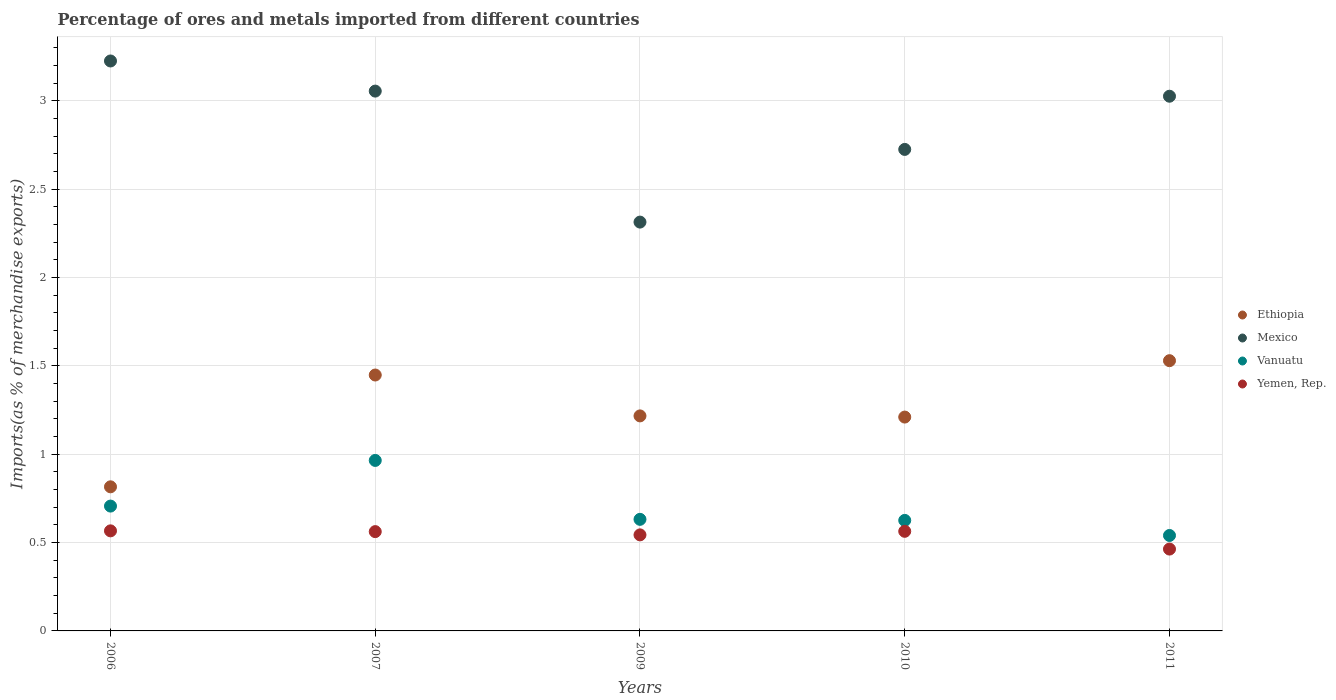Is the number of dotlines equal to the number of legend labels?
Your response must be concise. Yes. What is the percentage of imports to different countries in Yemen, Rep. in 2011?
Keep it short and to the point. 0.46. Across all years, what is the maximum percentage of imports to different countries in Mexico?
Keep it short and to the point. 3.23. Across all years, what is the minimum percentage of imports to different countries in Vanuatu?
Ensure brevity in your answer.  0.54. In which year was the percentage of imports to different countries in Ethiopia maximum?
Keep it short and to the point. 2011. In which year was the percentage of imports to different countries in Yemen, Rep. minimum?
Provide a short and direct response. 2011. What is the total percentage of imports to different countries in Ethiopia in the graph?
Your answer should be compact. 6.22. What is the difference between the percentage of imports to different countries in Mexico in 2006 and that in 2011?
Offer a terse response. 0.2. What is the difference between the percentage of imports to different countries in Mexico in 2010 and the percentage of imports to different countries in Vanuatu in 2007?
Offer a very short reply. 1.76. What is the average percentage of imports to different countries in Yemen, Rep. per year?
Your answer should be very brief. 0.54. In the year 2011, what is the difference between the percentage of imports to different countries in Ethiopia and percentage of imports to different countries in Vanuatu?
Ensure brevity in your answer.  0.99. In how many years, is the percentage of imports to different countries in Yemen, Rep. greater than 1.6 %?
Your response must be concise. 0. What is the ratio of the percentage of imports to different countries in Ethiopia in 2009 to that in 2010?
Offer a terse response. 1.01. What is the difference between the highest and the second highest percentage of imports to different countries in Mexico?
Ensure brevity in your answer.  0.17. What is the difference between the highest and the lowest percentage of imports to different countries in Vanuatu?
Your answer should be compact. 0.42. Does the percentage of imports to different countries in Mexico monotonically increase over the years?
Make the answer very short. No. Is the percentage of imports to different countries in Vanuatu strictly greater than the percentage of imports to different countries in Yemen, Rep. over the years?
Keep it short and to the point. Yes. Is the percentage of imports to different countries in Mexico strictly less than the percentage of imports to different countries in Ethiopia over the years?
Ensure brevity in your answer.  No. How many dotlines are there?
Keep it short and to the point. 4. Are the values on the major ticks of Y-axis written in scientific E-notation?
Your response must be concise. No. Does the graph contain any zero values?
Provide a succinct answer. No. Does the graph contain grids?
Provide a short and direct response. Yes. How many legend labels are there?
Keep it short and to the point. 4. How are the legend labels stacked?
Your response must be concise. Vertical. What is the title of the graph?
Your answer should be compact. Percentage of ores and metals imported from different countries. Does "Peru" appear as one of the legend labels in the graph?
Your answer should be very brief. No. What is the label or title of the Y-axis?
Make the answer very short. Imports(as % of merchandise exports). What is the Imports(as % of merchandise exports) in Ethiopia in 2006?
Ensure brevity in your answer.  0.82. What is the Imports(as % of merchandise exports) in Mexico in 2006?
Provide a succinct answer. 3.23. What is the Imports(as % of merchandise exports) in Vanuatu in 2006?
Keep it short and to the point. 0.71. What is the Imports(as % of merchandise exports) in Yemen, Rep. in 2006?
Make the answer very short. 0.57. What is the Imports(as % of merchandise exports) of Ethiopia in 2007?
Offer a very short reply. 1.45. What is the Imports(as % of merchandise exports) of Mexico in 2007?
Your response must be concise. 3.05. What is the Imports(as % of merchandise exports) of Vanuatu in 2007?
Offer a very short reply. 0.96. What is the Imports(as % of merchandise exports) of Yemen, Rep. in 2007?
Offer a terse response. 0.56. What is the Imports(as % of merchandise exports) in Ethiopia in 2009?
Keep it short and to the point. 1.22. What is the Imports(as % of merchandise exports) in Mexico in 2009?
Your response must be concise. 2.31. What is the Imports(as % of merchandise exports) in Vanuatu in 2009?
Your answer should be compact. 0.63. What is the Imports(as % of merchandise exports) of Yemen, Rep. in 2009?
Your answer should be compact. 0.54. What is the Imports(as % of merchandise exports) in Ethiopia in 2010?
Offer a terse response. 1.21. What is the Imports(as % of merchandise exports) of Mexico in 2010?
Keep it short and to the point. 2.72. What is the Imports(as % of merchandise exports) of Vanuatu in 2010?
Your answer should be compact. 0.63. What is the Imports(as % of merchandise exports) in Yemen, Rep. in 2010?
Provide a succinct answer. 0.56. What is the Imports(as % of merchandise exports) in Ethiopia in 2011?
Offer a very short reply. 1.53. What is the Imports(as % of merchandise exports) in Mexico in 2011?
Make the answer very short. 3.03. What is the Imports(as % of merchandise exports) in Vanuatu in 2011?
Give a very brief answer. 0.54. What is the Imports(as % of merchandise exports) in Yemen, Rep. in 2011?
Give a very brief answer. 0.46. Across all years, what is the maximum Imports(as % of merchandise exports) of Ethiopia?
Make the answer very short. 1.53. Across all years, what is the maximum Imports(as % of merchandise exports) in Mexico?
Make the answer very short. 3.23. Across all years, what is the maximum Imports(as % of merchandise exports) in Vanuatu?
Provide a short and direct response. 0.96. Across all years, what is the maximum Imports(as % of merchandise exports) of Yemen, Rep.?
Your answer should be very brief. 0.57. Across all years, what is the minimum Imports(as % of merchandise exports) of Ethiopia?
Give a very brief answer. 0.82. Across all years, what is the minimum Imports(as % of merchandise exports) of Mexico?
Your answer should be very brief. 2.31. Across all years, what is the minimum Imports(as % of merchandise exports) in Vanuatu?
Make the answer very short. 0.54. Across all years, what is the minimum Imports(as % of merchandise exports) of Yemen, Rep.?
Offer a very short reply. 0.46. What is the total Imports(as % of merchandise exports) in Ethiopia in the graph?
Ensure brevity in your answer.  6.22. What is the total Imports(as % of merchandise exports) of Mexico in the graph?
Make the answer very short. 14.35. What is the total Imports(as % of merchandise exports) in Vanuatu in the graph?
Your response must be concise. 3.47. What is the total Imports(as % of merchandise exports) of Yemen, Rep. in the graph?
Provide a succinct answer. 2.7. What is the difference between the Imports(as % of merchandise exports) of Ethiopia in 2006 and that in 2007?
Your answer should be very brief. -0.63. What is the difference between the Imports(as % of merchandise exports) of Mexico in 2006 and that in 2007?
Keep it short and to the point. 0.17. What is the difference between the Imports(as % of merchandise exports) in Vanuatu in 2006 and that in 2007?
Give a very brief answer. -0.26. What is the difference between the Imports(as % of merchandise exports) of Yemen, Rep. in 2006 and that in 2007?
Give a very brief answer. 0. What is the difference between the Imports(as % of merchandise exports) of Ethiopia in 2006 and that in 2009?
Make the answer very short. -0.4. What is the difference between the Imports(as % of merchandise exports) in Mexico in 2006 and that in 2009?
Ensure brevity in your answer.  0.91. What is the difference between the Imports(as % of merchandise exports) of Vanuatu in 2006 and that in 2009?
Give a very brief answer. 0.07. What is the difference between the Imports(as % of merchandise exports) of Yemen, Rep. in 2006 and that in 2009?
Your answer should be compact. 0.02. What is the difference between the Imports(as % of merchandise exports) in Ethiopia in 2006 and that in 2010?
Keep it short and to the point. -0.39. What is the difference between the Imports(as % of merchandise exports) of Mexico in 2006 and that in 2010?
Offer a terse response. 0.5. What is the difference between the Imports(as % of merchandise exports) of Vanuatu in 2006 and that in 2010?
Offer a very short reply. 0.08. What is the difference between the Imports(as % of merchandise exports) of Yemen, Rep. in 2006 and that in 2010?
Ensure brevity in your answer.  0. What is the difference between the Imports(as % of merchandise exports) in Ethiopia in 2006 and that in 2011?
Your answer should be compact. -0.71. What is the difference between the Imports(as % of merchandise exports) in Mexico in 2006 and that in 2011?
Keep it short and to the point. 0.2. What is the difference between the Imports(as % of merchandise exports) in Vanuatu in 2006 and that in 2011?
Your response must be concise. 0.17. What is the difference between the Imports(as % of merchandise exports) in Yemen, Rep. in 2006 and that in 2011?
Your answer should be very brief. 0.1. What is the difference between the Imports(as % of merchandise exports) of Ethiopia in 2007 and that in 2009?
Make the answer very short. 0.23. What is the difference between the Imports(as % of merchandise exports) of Mexico in 2007 and that in 2009?
Your answer should be very brief. 0.74. What is the difference between the Imports(as % of merchandise exports) of Vanuatu in 2007 and that in 2009?
Your answer should be compact. 0.33. What is the difference between the Imports(as % of merchandise exports) of Yemen, Rep. in 2007 and that in 2009?
Keep it short and to the point. 0.02. What is the difference between the Imports(as % of merchandise exports) in Ethiopia in 2007 and that in 2010?
Provide a succinct answer. 0.24. What is the difference between the Imports(as % of merchandise exports) of Mexico in 2007 and that in 2010?
Provide a succinct answer. 0.33. What is the difference between the Imports(as % of merchandise exports) of Vanuatu in 2007 and that in 2010?
Offer a terse response. 0.34. What is the difference between the Imports(as % of merchandise exports) in Yemen, Rep. in 2007 and that in 2010?
Offer a very short reply. -0. What is the difference between the Imports(as % of merchandise exports) in Ethiopia in 2007 and that in 2011?
Your response must be concise. -0.08. What is the difference between the Imports(as % of merchandise exports) of Mexico in 2007 and that in 2011?
Offer a terse response. 0.03. What is the difference between the Imports(as % of merchandise exports) of Vanuatu in 2007 and that in 2011?
Offer a terse response. 0.42. What is the difference between the Imports(as % of merchandise exports) of Yemen, Rep. in 2007 and that in 2011?
Ensure brevity in your answer.  0.1. What is the difference between the Imports(as % of merchandise exports) of Ethiopia in 2009 and that in 2010?
Offer a terse response. 0.01. What is the difference between the Imports(as % of merchandise exports) of Mexico in 2009 and that in 2010?
Offer a very short reply. -0.41. What is the difference between the Imports(as % of merchandise exports) in Vanuatu in 2009 and that in 2010?
Provide a short and direct response. 0.01. What is the difference between the Imports(as % of merchandise exports) in Yemen, Rep. in 2009 and that in 2010?
Give a very brief answer. -0.02. What is the difference between the Imports(as % of merchandise exports) in Ethiopia in 2009 and that in 2011?
Keep it short and to the point. -0.31. What is the difference between the Imports(as % of merchandise exports) of Mexico in 2009 and that in 2011?
Your response must be concise. -0.71. What is the difference between the Imports(as % of merchandise exports) of Vanuatu in 2009 and that in 2011?
Keep it short and to the point. 0.09. What is the difference between the Imports(as % of merchandise exports) in Yemen, Rep. in 2009 and that in 2011?
Make the answer very short. 0.08. What is the difference between the Imports(as % of merchandise exports) in Ethiopia in 2010 and that in 2011?
Your answer should be very brief. -0.32. What is the difference between the Imports(as % of merchandise exports) in Mexico in 2010 and that in 2011?
Your answer should be compact. -0.3. What is the difference between the Imports(as % of merchandise exports) in Vanuatu in 2010 and that in 2011?
Provide a succinct answer. 0.09. What is the difference between the Imports(as % of merchandise exports) of Yemen, Rep. in 2010 and that in 2011?
Offer a very short reply. 0.1. What is the difference between the Imports(as % of merchandise exports) of Ethiopia in 2006 and the Imports(as % of merchandise exports) of Mexico in 2007?
Your response must be concise. -2.24. What is the difference between the Imports(as % of merchandise exports) in Ethiopia in 2006 and the Imports(as % of merchandise exports) in Vanuatu in 2007?
Provide a short and direct response. -0.15. What is the difference between the Imports(as % of merchandise exports) in Ethiopia in 2006 and the Imports(as % of merchandise exports) in Yemen, Rep. in 2007?
Offer a terse response. 0.25. What is the difference between the Imports(as % of merchandise exports) in Mexico in 2006 and the Imports(as % of merchandise exports) in Vanuatu in 2007?
Give a very brief answer. 2.26. What is the difference between the Imports(as % of merchandise exports) in Mexico in 2006 and the Imports(as % of merchandise exports) in Yemen, Rep. in 2007?
Give a very brief answer. 2.66. What is the difference between the Imports(as % of merchandise exports) in Vanuatu in 2006 and the Imports(as % of merchandise exports) in Yemen, Rep. in 2007?
Ensure brevity in your answer.  0.14. What is the difference between the Imports(as % of merchandise exports) of Ethiopia in 2006 and the Imports(as % of merchandise exports) of Mexico in 2009?
Provide a succinct answer. -1.5. What is the difference between the Imports(as % of merchandise exports) of Ethiopia in 2006 and the Imports(as % of merchandise exports) of Vanuatu in 2009?
Keep it short and to the point. 0.18. What is the difference between the Imports(as % of merchandise exports) of Ethiopia in 2006 and the Imports(as % of merchandise exports) of Yemen, Rep. in 2009?
Provide a succinct answer. 0.27. What is the difference between the Imports(as % of merchandise exports) in Mexico in 2006 and the Imports(as % of merchandise exports) in Vanuatu in 2009?
Offer a very short reply. 2.59. What is the difference between the Imports(as % of merchandise exports) in Mexico in 2006 and the Imports(as % of merchandise exports) in Yemen, Rep. in 2009?
Your answer should be very brief. 2.68. What is the difference between the Imports(as % of merchandise exports) of Vanuatu in 2006 and the Imports(as % of merchandise exports) of Yemen, Rep. in 2009?
Make the answer very short. 0.16. What is the difference between the Imports(as % of merchandise exports) in Ethiopia in 2006 and the Imports(as % of merchandise exports) in Mexico in 2010?
Offer a very short reply. -1.91. What is the difference between the Imports(as % of merchandise exports) in Ethiopia in 2006 and the Imports(as % of merchandise exports) in Vanuatu in 2010?
Your response must be concise. 0.19. What is the difference between the Imports(as % of merchandise exports) of Ethiopia in 2006 and the Imports(as % of merchandise exports) of Yemen, Rep. in 2010?
Your answer should be compact. 0.25. What is the difference between the Imports(as % of merchandise exports) in Mexico in 2006 and the Imports(as % of merchandise exports) in Vanuatu in 2010?
Keep it short and to the point. 2.6. What is the difference between the Imports(as % of merchandise exports) of Mexico in 2006 and the Imports(as % of merchandise exports) of Yemen, Rep. in 2010?
Your answer should be compact. 2.66. What is the difference between the Imports(as % of merchandise exports) in Vanuatu in 2006 and the Imports(as % of merchandise exports) in Yemen, Rep. in 2010?
Keep it short and to the point. 0.14. What is the difference between the Imports(as % of merchandise exports) in Ethiopia in 2006 and the Imports(as % of merchandise exports) in Mexico in 2011?
Your answer should be very brief. -2.21. What is the difference between the Imports(as % of merchandise exports) in Ethiopia in 2006 and the Imports(as % of merchandise exports) in Vanuatu in 2011?
Offer a terse response. 0.28. What is the difference between the Imports(as % of merchandise exports) of Ethiopia in 2006 and the Imports(as % of merchandise exports) of Yemen, Rep. in 2011?
Give a very brief answer. 0.35. What is the difference between the Imports(as % of merchandise exports) of Mexico in 2006 and the Imports(as % of merchandise exports) of Vanuatu in 2011?
Give a very brief answer. 2.69. What is the difference between the Imports(as % of merchandise exports) of Mexico in 2006 and the Imports(as % of merchandise exports) of Yemen, Rep. in 2011?
Offer a terse response. 2.76. What is the difference between the Imports(as % of merchandise exports) of Vanuatu in 2006 and the Imports(as % of merchandise exports) of Yemen, Rep. in 2011?
Keep it short and to the point. 0.24. What is the difference between the Imports(as % of merchandise exports) in Ethiopia in 2007 and the Imports(as % of merchandise exports) in Mexico in 2009?
Your response must be concise. -0.87. What is the difference between the Imports(as % of merchandise exports) in Ethiopia in 2007 and the Imports(as % of merchandise exports) in Vanuatu in 2009?
Your answer should be compact. 0.82. What is the difference between the Imports(as % of merchandise exports) of Ethiopia in 2007 and the Imports(as % of merchandise exports) of Yemen, Rep. in 2009?
Ensure brevity in your answer.  0.9. What is the difference between the Imports(as % of merchandise exports) of Mexico in 2007 and the Imports(as % of merchandise exports) of Vanuatu in 2009?
Give a very brief answer. 2.42. What is the difference between the Imports(as % of merchandise exports) of Mexico in 2007 and the Imports(as % of merchandise exports) of Yemen, Rep. in 2009?
Keep it short and to the point. 2.51. What is the difference between the Imports(as % of merchandise exports) of Vanuatu in 2007 and the Imports(as % of merchandise exports) of Yemen, Rep. in 2009?
Keep it short and to the point. 0.42. What is the difference between the Imports(as % of merchandise exports) of Ethiopia in 2007 and the Imports(as % of merchandise exports) of Mexico in 2010?
Offer a terse response. -1.28. What is the difference between the Imports(as % of merchandise exports) in Ethiopia in 2007 and the Imports(as % of merchandise exports) in Vanuatu in 2010?
Offer a very short reply. 0.82. What is the difference between the Imports(as % of merchandise exports) of Ethiopia in 2007 and the Imports(as % of merchandise exports) of Yemen, Rep. in 2010?
Provide a succinct answer. 0.88. What is the difference between the Imports(as % of merchandise exports) in Mexico in 2007 and the Imports(as % of merchandise exports) in Vanuatu in 2010?
Give a very brief answer. 2.43. What is the difference between the Imports(as % of merchandise exports) of Mexico in 2007 and the Imports(as % of merchandise exports) of Yemen, Rep. in 2010?
Your answer should be compact. 2.49. What is the difference between the Imports(as % of merchandise exports) of Vanuatu in 2007 and the Imports(as % of merchandise exports) of Yemen, Rep. in 2010?
Offer a very short reply. 0.4. What is the difference between the Imports(as % of merchandise exports) of Ethiopia in 2007 and the Imports(as % of merchandise exports) of Mexico in 2011?
Make the answer very short. -1.58. What is the difference between the Imports(as % of merchandise exports) of Ethiopia in 2007 and the Imports(as % of merchandise exports) of Vanuatu in 2011?
Your answer should be very brief. 0.91. What is the difference between the Imports(as % of merchandise exports) of Mexico in 2007 and the Imports(as % of merchandise exports) of Vanuatu in 2011?
Offer a terse response. 2.51. What is the difference between the Imports(as % of merchandise exports) of Mexico in 2007 and the Imports(as % of merchandise exports) of Yemen, Rep. in 2011?
Provide a short and direct response. 2.59. What is the difference between the Imports(as % of merchandise exports) in Vanuatu in 2007 and the Imports(as % of merchandise exports) in Yemen, Rep. in 2011?
Your response must be concise. 0.5. What is the difference between the Imports(as % of merchandise exports) in Ethiopia in 2009 and the Imports(as % of merchandise exports) in Mexico in 2010?
Your answer should be very brief. -1.51. What is the difference between the Imports(as % of merchandise exports) in Ethiopia in 2009 and the Imports(as % of merchandise exports) in Vanuatu in 2010?
Your answer should be very brief. 0.59. What is the difference between the Imports(as % of merchandise exports) of Ethiopia in 2009 and the Imports(as % of merchandise exports) of Yemen, Rep. in 2010?
Offer a terse response. 0.65. What is the difference between the Imports(as % of merchandise exports) of Mexico in 2009 and the Imports(as % of merchandise exports) of Vanuatu in 2010?
Make the answer very short. 1.69. What is the difference between the Imports(as % of merchandise exports) of Mexico in 2009 and the Imports(as % of merchandise exports) of Yemen, Rep. in 2010?
Give a very brief answer. 1.75. What is the difference between the Imports(as % of merchandise exports) in Vanuatu in 2009 and the Imports(as % of merchandise exports) in Yemen, Rep. in 2010?
Your answer should be very brief. 0.07. What is the difference between the Imports(as % of merchandise exports) of Ethiopia in 2009 and the Imports(as % of merchandise exports) of Mexico in 2011?
Provide a short and direct response. -1.81. What is the difference between the Imports(as % of merchandise exports) of Ethiopia in 2009 and the Imports(as % of merchandise exports) of Vanuatu in 2011?
Offer a very short reply. 0.68. What is the difference between the Imports(as % of merchandise exports) in Ethiopia in 2009 and the Imports(as % of merchandise exports) in Yemen, Rep. in 2011?
Provide a succinct answer. 0.75. What is the difference between the Imports(as % of merchandise exports) in Mexico in 2009 and the Imports(as % of merchandise exports) in Vanuatu in 2011?
Offer a very short reply. 1.77. What is the difference between the Imports(as % of merchandise exports) of Mexico in 2009 and the Imports(as % of merchandise exports) of Yemen, Rep. in 2011?
Your answer should be compact. 1.85. What is the difference between the Imports(as % of merchandise exports) in Vanuatu in 2009 and the Imports(as % of merchandise exports) in Yemen, Rep. in 2011?
Provide a short and direct response. 0.17. What is the difference between the Imports(as % of merchandise exports) in Ethiopia in 2010 and the Imports(as % of merchandise exports) in Mexico in 2011?
Provide a succinct answer. -1.82. What is the difference between the Imports(as % of merchandise exports) in Ethiopia in 2010 and the Imports(as % of merchandise exports) in Vanuatu in 2011?
Your answer should be compact. 0.67. What is the difference between the Imports(as % of merchandise exports) in Ethiopia in 2010 and the Imports(as % of merchandise exports) in Yemen, Rep. in 2011?
Offer a very short reply. 0.75. What is the difference between the Imports(as % of merchandise exports) of Mexico in 2010 and the Imports(as % of merchandise exports) of Vanuatu in 2011?
Keep it short and to the point. 2.18. What is the difference between the Imports(as % of merchandise exports) in Mexico in 2010 and the Imports(as % of merchandise exports) in Yemen, Rep. in 2011?
Your answer should be very brief. 2.26. What is the difference between the Imports(as % of merchandise exports) in Vanuatu in 2010 and the Imports(as % of merchandise exports) in Yemen, Rep. in 2011?
Offer a very short reply. 0.16. What is the average Imports(as % of merchandise exports) in Ethiopia per year?
Offer a terse response. 1.24. What is the average Imports(as % of merchandise exports) of Mexico per year?
Give a very brief answer. 2.87. What is the average Imports(as % of merchandise exports) in Vanuatu per year?
Your response must be concise. 0.69. What is the average Imports(as % of merchandise exports) in Yemen, Rep. per year?
Provide a succinct answer. 0.54. In the year 2006, what is the difference between the Imports(as % of merchandise exports) in Ethiopia and Imports(as % of merchandise exports) in Mexico?
Make the answer very short. -2.41. In the year 2006, what is the difference between the Imports(as % of merchandise exports) of Ethiopia and Imports(as % of merchandise exports) of Vanuatu?
Provide a short and direct response. 0.11. In the year 2006, what is the difference between the Imports(as % of merchandise exports) of Ethiopia and Imports(as % of merchandise exports) of Yemen, Rep.?
Give a very brief answer. 0.25. In the year 2006, what is the difference between the Imports(as % of merchandise exports) of Mexico and Imports(as % of merchandise exports) of Vanuatu?
Ensure brevity in your answer.  2.52. In the year 2006, what is the difference between the Imports(as % of merchandise exports) of Mexico and Imports(as % of merchandise exports) of Yemen, Rep.?
Offer a terse response. 2.66. In the year 2006, what is the difference between the Imports(as % of merchandise exports) in Vanuatu and Imports(as % of merchandise exports) in Yemen, Rep.?
Make the answer very short. 0.14. In the year 2007, what is the difference between the Imports(as % of merchandise exports) in Ethiopia and Imports(as % of merchandise exports) in Mexico?
Your answer should be very brief. -1.61. In the year 2007, what is the difference between the Imports(as % of merchandise exports) in Ethiopia and Imports(as % of merchandise exports) in Vanuatu?
Offer a terse response. 0.48. In the year 2007, what is the difference between the Imports(as % of merchandise exports) in Ethiopia and Imports(as % of merchandise exports) in Yemen, Rep.?
Your answer should be compact. 0.89. In the year 2007, what is the difference between the Imports(as % of merchandise exports) of Mexico and Imports(as % of merchandise exports) of Vanuatu?
Your response must be concise. 2.09. In the year 2007, what is the difference between the Imports(as % of merchandise exports) of Mexico and Imports(as % of merchandise exports) of Yemen, Rep.?
Your response must be concise. 2.49. In the year 2007, what is the difference between the Imports(as % of merchandise exports) in Vanuatu and Imports(as % of merchandise exports) in Yemen, Rep.?
Offer a terse response. 0.4. In the year 2009, what is the difference between the Imports(as % of merchandise exports) in Ethiopia and Imports(as % of merchandise exports) in Mexico?
Ensure brevity in your answer.  -1.1. In the year 2009, what is the difference between the Imports(as % of merchandise exports) in Ethiopia and Imports(as % of merchandise exports) in Vanuatu?
Offer a terse response. 0.59. In the year 2009, what is the difference between the Imports(as % of merchandise exports) in Ethiopia and Imports(as % of merchandise exports) in Yemen, Rep.?
Make the answer very short. 0.67. In the year 2009, what is the difference between the Imports(as % of merchandise exports) in Mexico and Imports(as % of merchandise exports) in Vanuatu?
Give a very brief answer. 1.68. In the year 2009, what is the difference between the Imports(as % of merchandise exports) of Mexico and Imports(as % of merchandise exports) of Yemen, Rep.?
Your response must be concise. 1.77. In the year 2009, what is the difference between the Imports(as % of merchandise exports) in Vanuatu and Imports(as % of merchandise exports) in Yemen, Rep.?
Your answer should be compact. 0.09. In the year 2010, what is the difference between the Imports(as % of merchandise exports) in Ethiopia and Imports(as % of merchandise exports) in Mexico?
Make the answer very short. -1.51. In the year 2010, what is the difference between the Imports(as % of merchandise exports) in Ethiopia and Imports(as % of merchandise exports) in Vanuatu?
Offer a terse response. 0.58. In the year 2010, what is the difference between the Imports(as % of merchandise exports) of Ethiopia and Imports(as % of merchandise exports) of Yemen, Rep.?
Your answer should be compact. 0.65. In the year 2010, what is the difference between the Imports(as % of merchandise exports) in Mexico and Imports(as % of merchandise exports) in Vanuatu?
Your answer should be compact. 2.1. In the year 2010, what is the difference between the Imports(as % of merchandise exports) of Mexico and Imports(as % of merchandise exports) of Yemen, Rep.?
Offer a terse response. 2.16. In the year 2010, what is the difference between the Imports(as % of merchandise exports) in Vanuatu and Imports(as % of merchandise exports) in Yemen, Rep.?
Keep it short and to the point. 0.06. In the year 2011, what is the difference between the Imports(as % of merchandise exports) of Ethiopia and Imports(as % of merchandise exports) of Mexico?
Provide a succinct answer. -1.5. In the year 2011, what is the difference between the Imports(as % of merchandise exports) of Ethiopia and Imports(as % of merchandise exports) of Yemen, Rep.?
Give a very brief answer. 1.07. In the year 2011, what is the difference between the Imports(as % of merchandise exports) of Mexico and Imports(as % of merchandise exports) of Vanuatu?
Your answer should be compact. 2.49. In the year 2011, what is the difference between the Imports(as % of merchandise exports) of Mexico and Imports(as % of merchandise exports) of Yemen, Rep.?
Offer a terse response. 2.56. In the year 2011, what is the difference between the Imports(as % of merchandise exports) in Vanuatu and Imports(as % of merchandise exports) in Yemen, Rep.?
Make the answer very short. 0.08. What is the ratio of the Imports(as % of merchandise exports) of Ethiopia in 2006 to that in 2007?
Offer a terse response. 0.56. What is the ratio of the Imports(as % of merchandise exports) of Mexico in 2006 to that in 2007?
Offer a very short reply. 1.06. What is the ratio of the Imports(as % of merchandise exports) of Vanuatu in 2006 to that in 2007?
Offer a terse response. 0.73. What is the ratio of the Imports(as % of merchandise exports) in Yemen, Rep. in 2006 to that in 2007?
Provide a succinct answer. 1.01. What is the ratio of the Imports(as % of merchandise exports) of Ethiopia in 2006 to that in 2009?
Your answer should be compact. 0.67. What is the ratio of the Imports(as % of merchandise exports) in Mexico in 2006 to that in 2009?
Offer a terse response. 1.39. What is the ratio of the Imports(as % of merchandise exports) of Vanuatu in 2006 to that in 2009?
Keep it short and to the point. 1.12. What is the ratio of the Imports(as % of merchandise exports) in Yemen, Rep. in 2006 to that in 2009?
Provide a succinct answer. 1.04. What is the ratio of the Imports(as % of merchandise exports) of Ethiopia in 2006 to that in 2010?
Keep it short and to the point. 0.67. What is the ratio of the Imports(as % of merchandise exports) of Mexico in 2006 to that in 2010?
Your response must be concise. 1.18. What is the ratio of the Imports(as % of merchandise exports) in Vanuatu in 2006 to that in 2010?
Provide a succinct answer. 1.13. What is the ratio of the Imports(as % of merchandise exports) in Yemen, Rep. in 2006 to that in 2010?
Your answer should be very brief. 1. What is the ratio of the Imports(as % of merchandise exports) of Ethiopia in 2006 to that in 2011?
Your answer should be compact. 0.53. What is the ratio of the Imports(as % of merchandise exports) in Mexico in 2006 to that in 2011?
Keep it short and to the point. 1.07. What is the ratio of the Imports(as % of merchandise exports) of Vanuatu in 2006 to that in 2011?
Make the answer very short. 1.31. What is the ratio of the Imports(as % of merchandise exports) in Yemen, Rep. in 2006 to that in 2011?
Make the answer very short. 1.22. What is the ratio of the Imports(as % of merchandise exports) of Ethiopia in 2007 to that in 2009?
Keep it short and to the point. 1.19. What is the ratio of the Imports(as % of merchandise exports) in Mexico in 2007 to that in 2009?
Make the answer very short. 1.32. What is the ratio of the Imports(as % of merchandise exports) in Vanuatu in 2007 to that in 2009?
Offer a terse response. 1.53. What is the ratio of the Imports(as % of merchandise exports) of Yemen, Rep. in 2007 to that in 2009?
Give a very brief answer. 1.03. What is the ratio of the Imports(as % of merchandise exports) in Ethiopia in 2007 to that in 2010?
Keep it short and to the point. 1.2. What is the ratio of the Imports(as % of merchandise exports) in Mexico in 2007 to that in 2010?
Make the answer very short. 1.12. What is the ratio of the Imports(as % of merchandise exports) in Vanuatu in 2007 to that in 2010?
Ensure brevity in your answer.  1.54. What is the ratio of the Imports(as % of merchandise exports) in Ethiopia in 2007 to that in 2011?
Provide a short and direct response. 0.95. What is the ratio of the Imports(as % of merchandise exports) of Mexico in 2007 to that in 2011?
Your answer should be very brief. 1.01. What is the ratio of the Imports(as % of merchandise exports) of Vanuatu in 2007 to that in 2011?
Make the answer very short. 1.79. What is the ratio of the Imports(as % of merchandise exports) in Yemen, Rep. in 2007 to that in 2011?
Your answer should be very brief. 1.21. What is the ratio of the Imports(as % of merchandise exports) of Ethiopia in 2009 to that in 2010?
Your answer should be very brief. 1.01. What is the ratio of the Imports(as % of merchandise exports) of Mexico in 2009 to that in 2010?
Give a very brief answer. 0.85. What is the ratio of the Imports(as % of merchandise exports) of Vanuatu in 2009 to that in 2010?
Your answer should be very brief. 1.01. What is the ratio of the Imports(as % of merchandise exports) of Ethiopia in 2009 to that in 2011?
Keep it short and to the point. 0.8. What is the ratio of the Imports(as % of merchandise exports) of Mexico in 2009 to that in 2011?
Offer a terse response. 0.76. What is the ratio of the Imports(as % of merchandise exports) in Vanuatu in 2009 to that in 2011?
Provide a succinct answer. 1.17. What is the ratio of the Imports(as % of merchandise exports) in Yemen, Rep. in 2009 to that in 2011?
Your answer should be compact. 1.17. What is the ratio of the Imports(as % of merchandise exports) in Ethiopia in 2010 to that in 2011?
Make the answer very short. 0.79. What is the ratio of the Imports(as % of merchandise exports) of Mexico in 2010 to that in 2011?
Make the answer very short. 0.9. What is the ratio of the Imports(as % of merchandise exports) in Vanuatu in 2010 to that in 2011?
Give a very brief answer. 1.16. What is the ratio of the Imports(as % of merchandise exports) in Yemen, Rep. in 2010 to that in 2011?
Provide a short and direct response. 1.22. What is the difference between the highest and the second highest Imports(as % of merchandise exports) of Ethiopia?
Your answer should be very brief. 0.08. What is the difference between the highest and the second highest Imports(as % of merchandise exports) in Mexico?
Your answer should be very brief. 0.17. What is the difference between the highest and the second highest Imports(as % of merchandise exports) in Vanuatu?
Provide a short and direct response. 0.26. What is the difference between the highest and the second highest Imports(as % of merchandise exports) in Yemen, Rep.?
Keep it short and to the point. 0. What is the difference between the highest and the lowest Imports(as % of merchandise exports) of Ethiopia?
Give a very brief answer. 0.71. What is the difference between the highest and the lowest Imports(as % of merchandise exports) in Mexico?
Your answer should be very brief. 0.91. What is the difference between the highest and the lowest Imports(as % of merchandise exports) of Vanuatu?
Give a very brief answer. 0.42. What is the difference between the highest and the lowest Imports(as % of merchandise exports) in Yemen, Rep.?
Your answer should be very brief. 0.1. 